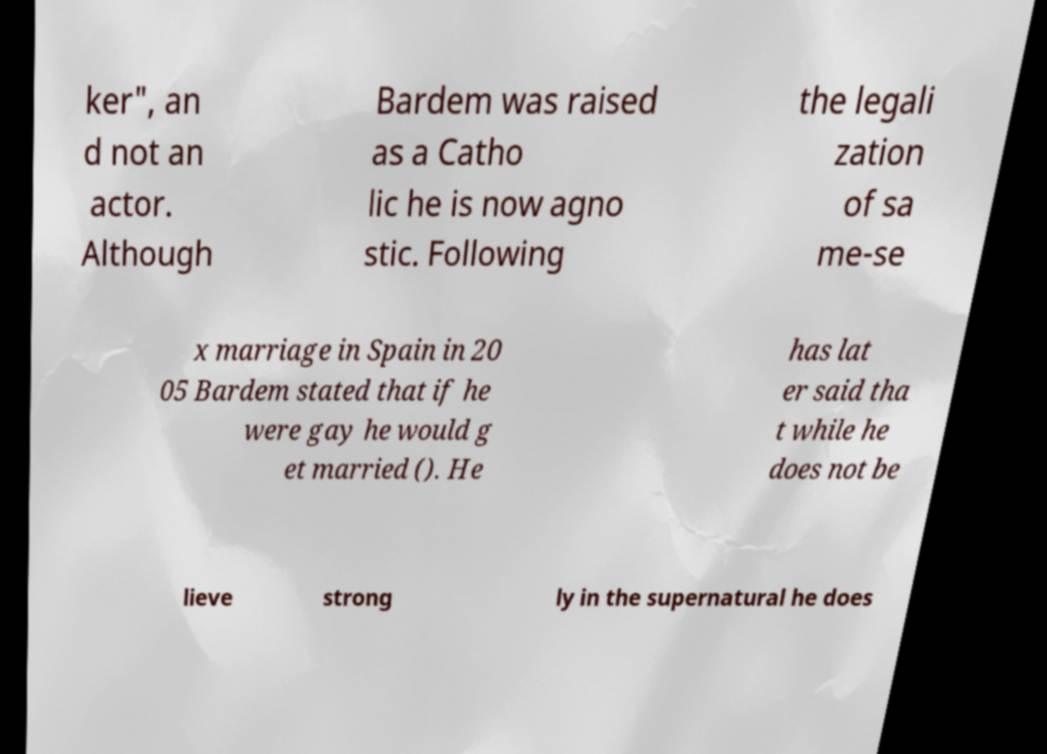There's text embedded in this image that I need extracted. Can you transcribe it verbatim? ker", an d not an actor. Although Bardem was raised as a Catho lic he is now agno stic. Following the legali zation of sa me-se x marriage in Spain in 20 05 Bardem stated that if he were gay he would g et married (). He has lat er said tha t while he does not be lieve strong ly in the supernatural he does 